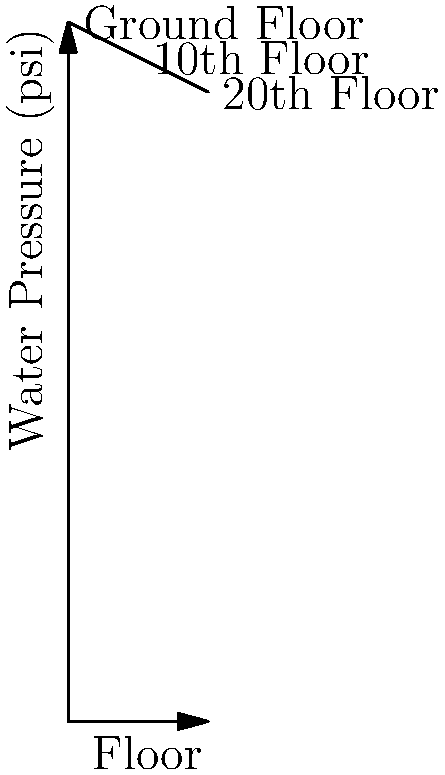In your 20-story apartment building, water pressure decreases by 0.5 psi per floor from the ground level. If the water pressure at the ground floor is 100 psi, what is the minimum booster pump pressure needed to ensure at least 40 psi of water pressure on the top floor? To solve this problem, we need to follow these steps:

1. Calculate the water pressure loss from ground floor to the 20th floor:
   Pressure loss = 0.5 psi/floor × 20 floors = 10 psi

2. Calculate the remaining pressure on the 20th floor without a booster pump:
   Remaining pressure = 100 psi - 10 psi = 90 psi

3. Compare the remaining pressure to the required minimum pressure:
   90 psi > 40 psi (minimum required)

4. Determine if a booster pump is needed:
   Since the remaining pressure (90 psi) is greater than the minimum required pressure (40 psi), no booster pump is needed.

5. Calculate the minimum booster pump pressure:
   Minimum booster pump pressure = 0 psi

The water pressure at the top floor is sufficient without a booster pump, so the minimum booster pump pressure needed is 0 psi.
Answer: 0 psi 